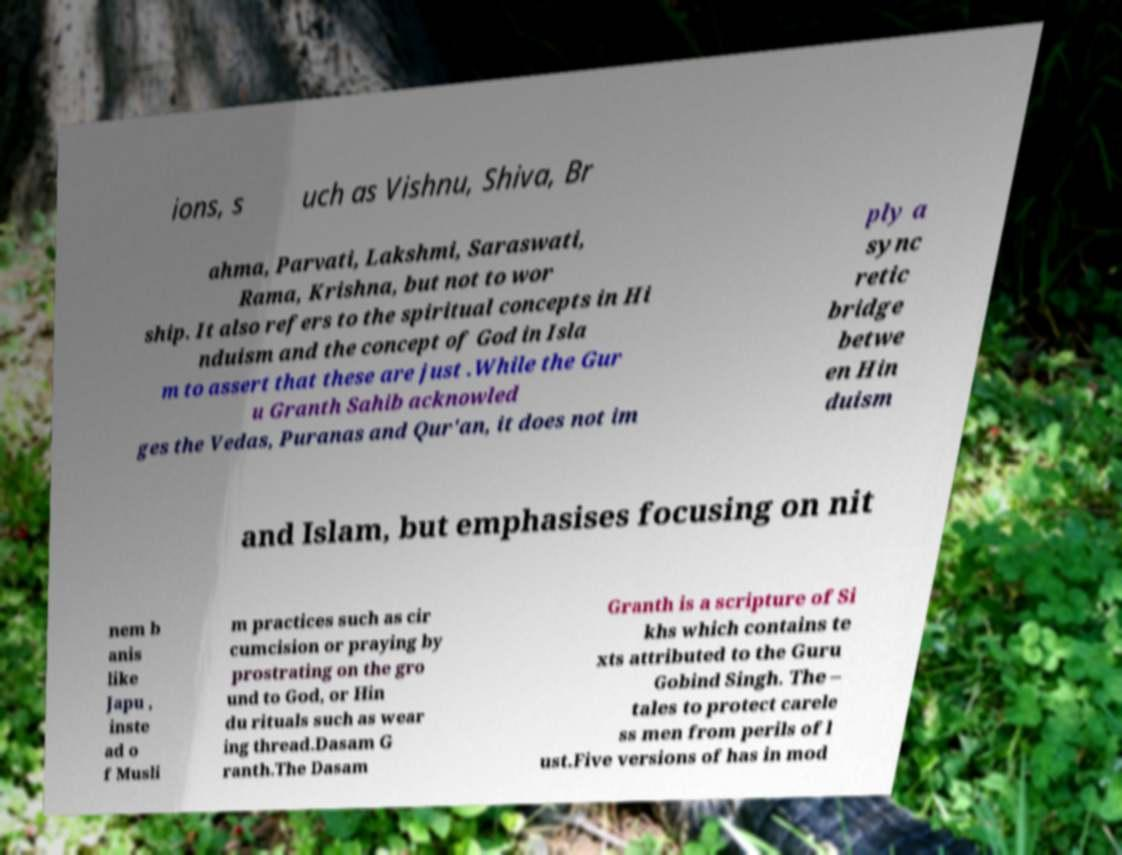Please read and relay the text visible in this image. What does it say? ions, s uch as Vishnu, Shiva, Br ahma, Parvati, Lakshmi, Saraswati, Rama, Krishna, but not to wor ship. It also refers to the spiritual concepts in Hi nduism and the concept of God in Isla m to assert that these are just .While the Gur u Granth Sahib acknowled ges the Vedas, Puranas and Qur'an, it does not im ply a sync retic bridge betwe en Hin duism and Islam, but emphasises focusing on nit nem b anis like Japu , inste ad o f Musli m practices such as cir cumcision or praying by prostrating on the gro und to God, or Hin du rituals such as wear ing thread.Dasam G ranth.The Dasam Granth is a scripture of Si khs which contains te xts attributed to the Guru Gobind Singh. The – tales to protect carele ss men from perils of l ust.Five versions of has in mod 